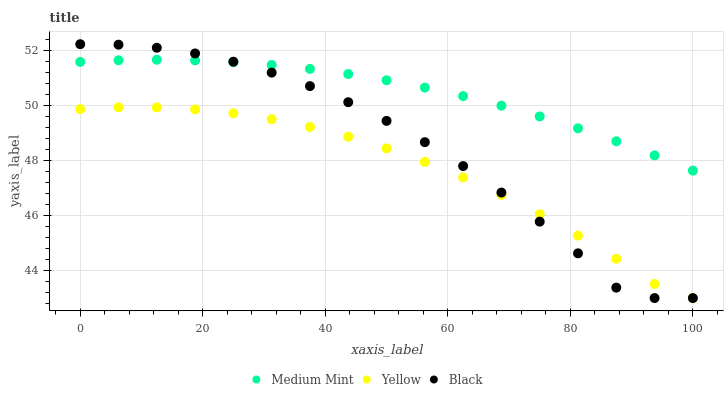Does Yellow have the minimum area under the curve?
Answer yes or no. Yes. Does Medium Mint have the maximum area under the curve?
Answer yes or no. Yes. Does Black have the minimum area under the curve?
Answer yes or no. No. Does Black have the maximum area under the curve?
Answer yes or no. No. Is Medium Mint the smoothest?
Answer yes or no. Yes. Is Black the roughest?
Answer yes or no. Yes. Is Yellow the smoothest?
Answer yes or no. No. Is Yellow the roughest?
Answer yes or no. No. Does Black have the lowest value?
Answer yes or no. Yes. Does Black have the highest value?
Answer yes or no. Yes. Does Yellow have the highest value?
Answer yes or no. No. Is Yellow less than Medium Mint?
Answer yes or no. Yes. Is Medium Mint greater than Yellow?
Answer yes or no. Yes. Does Medium Mint intersect Black?
Answer yes or no. Yes. Is Medium Mint less than Black?
Answer yes or no. No. Is Medium Mint greater than Black?
Answer yes or no. No. Does Yellow intersect Medium Mint?
Answer yes or no. No. 